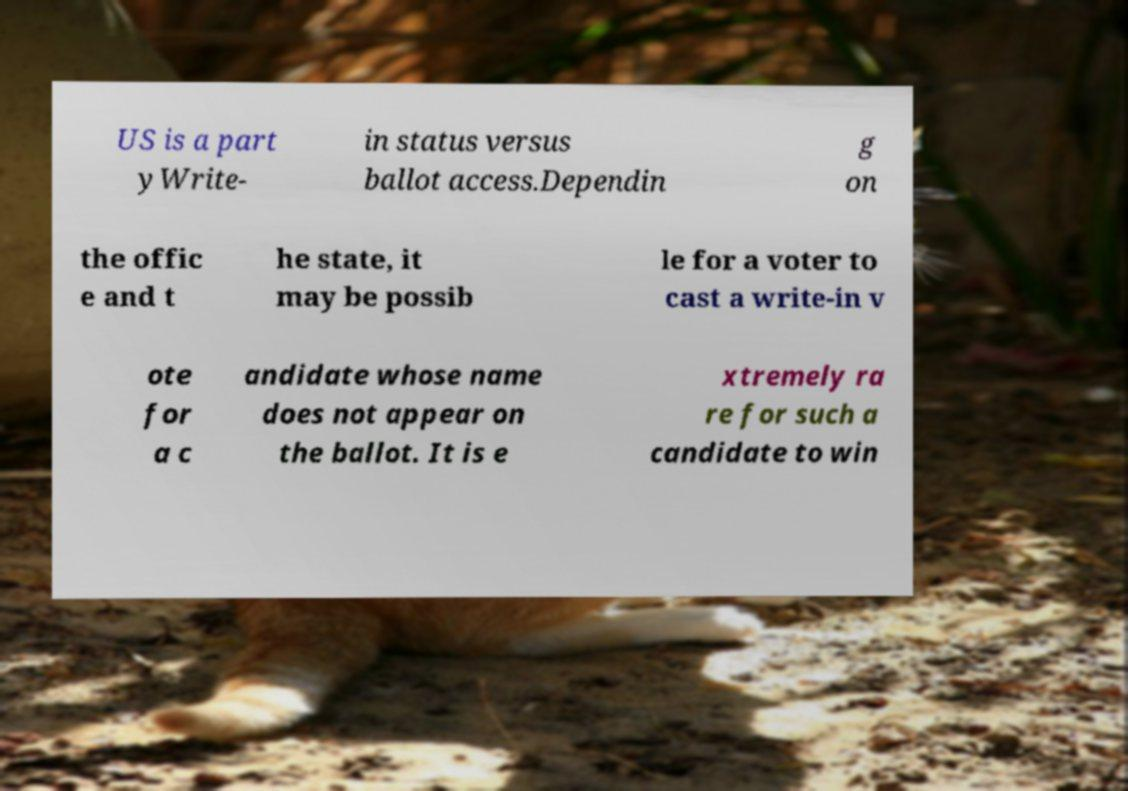Could you extract and type out the text from this image? US is a part yWrite- in status versus ballot access.Dependin g on the offic e and t he state, it may be possib le for a voter to cast a write-in v ote for a c andidate whose name does not appear on the ballot. It is e xtremely ra re for such a candidate to win 